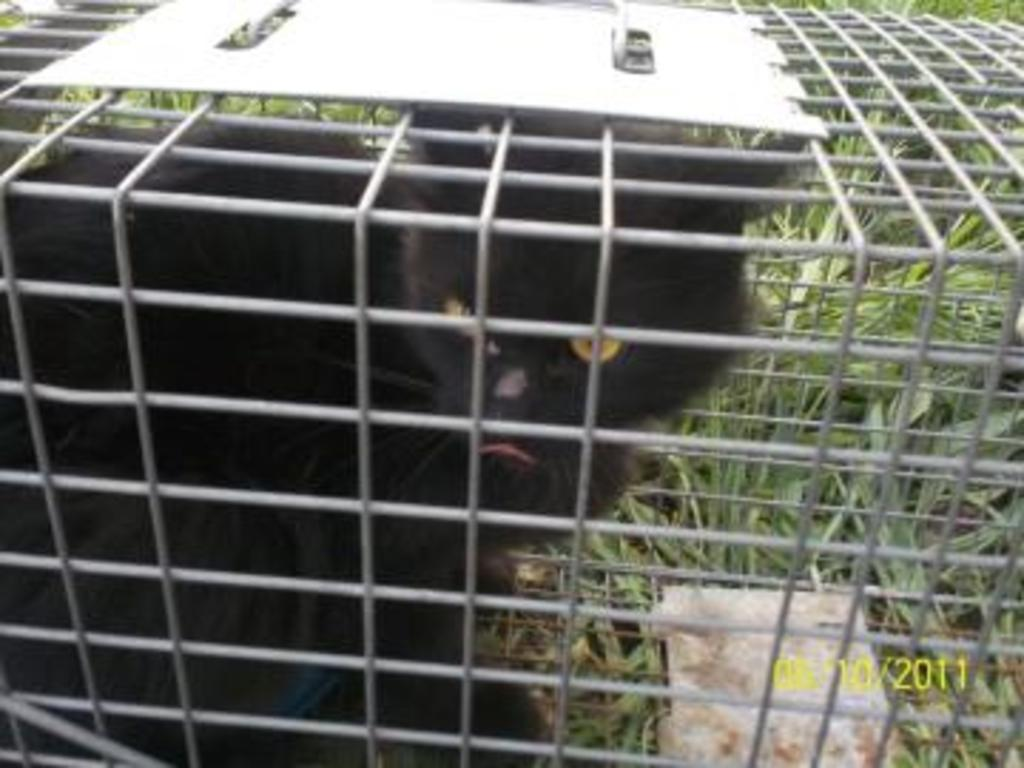What type of animal is in the image? There is a black cat in the image. How is the cat contained in the image? The cat is placed in a closed box. What is the surface beneath the box in the image? The box is placed on grass. Is there any additional information provided in the image? Yes, there is a date visible in the bottom right corner of the image. What type of sign can be seen in the image? There is no sign present in the image; it features a black cat in a closed box placed on grass. How does the cat's digestion process appear in the image? The image does not show the cat's digestion process; it only shows the cat in a closed box on grass. 